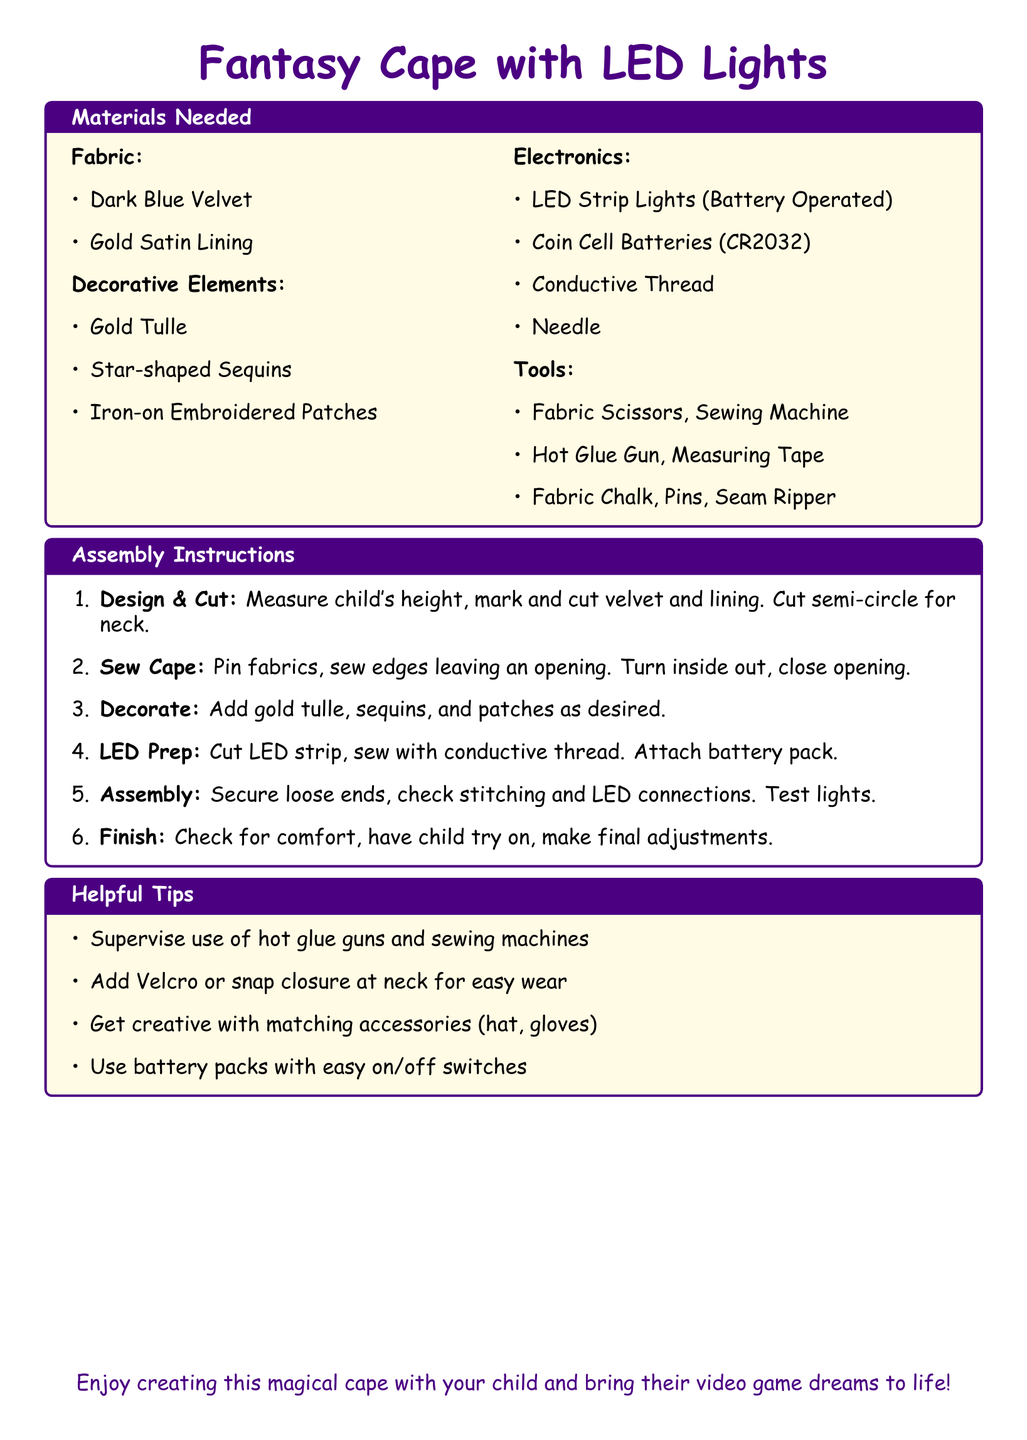What are the main fabric types needed? The main fabric types listed in the materials needed section are Dark Blue Velvet and Gold Satin Lining.
Answer: Dark Blue Velvet, Gold Satin Lining How many LED Strip Lights are required? The instruction mentions using LED Strip Lights that are battery operated but does not specify a quantity needed; typically, one strip is used.
Answer: One What type of batteries are used? The types of batteries needed for the LED integration are mentioned as Coin Cell Batteries.
Answer: Coin Cell Batteries What is the third step in the assembly instructions? The third step in the assembly instructions is about decorating the cape with additional elements.
Answer: Decorate What is a suggested closure method for the neck? The helpful tips section suggests adding Velcro or snap closure for ease.
Answer: Velcro or snap closure How should the LED strip be attached? The assembly instructions state that the LED strip should be sewn with conductive thread.
Answer: Sew with conductive thread What should be checked after assembling the cape? The assembly section advises checking the stitching and LED connections after securing loose ends.
Answer: Check stitching and LED connections What tool is used for cutting fabric? The tools section lists Fabric Scissors as necessary for cutting fabric.
Answer: Fabric Scissors 